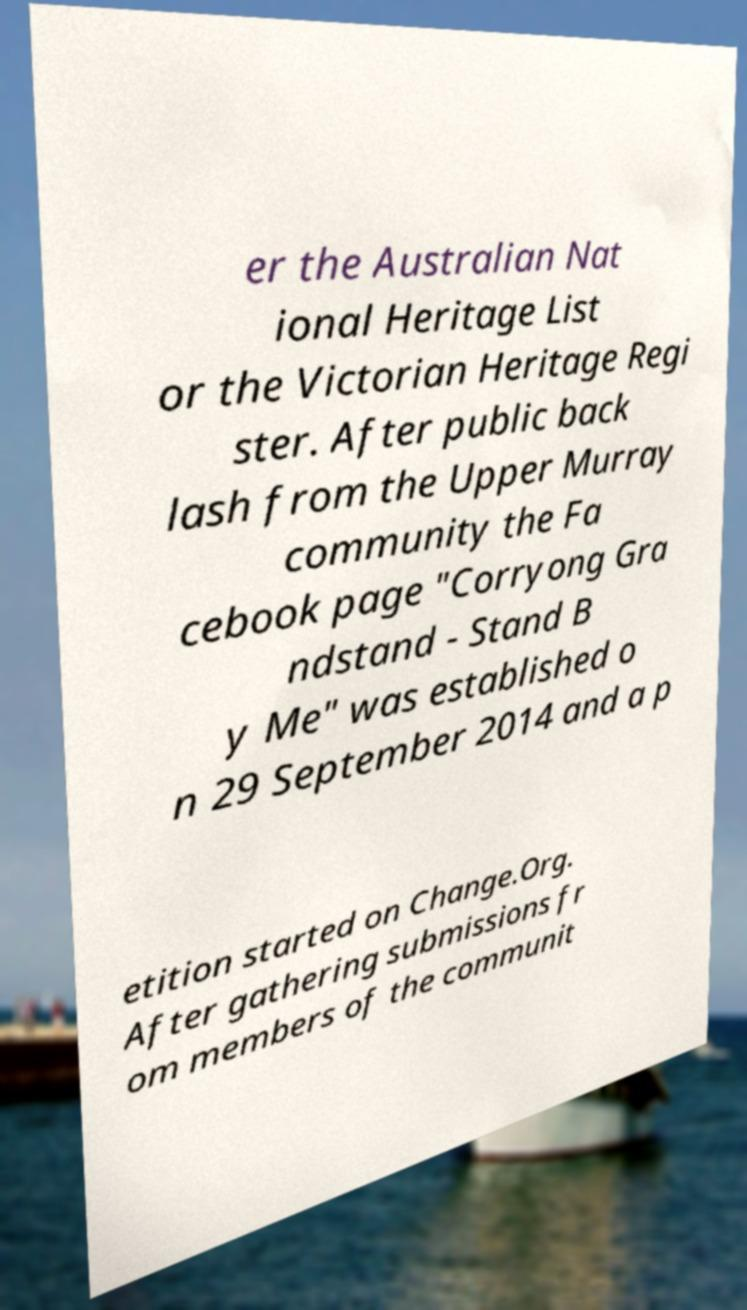What messages or text are displayed in this image? I need them in a readable, typed format. er the Australian Nat ional Heritage List or the Victorian Heritage Regi ster. After public back lash from the Upper Murray community the Fa cebook page "Corryong Gra ndstand - Stand B y Me" was established o n 29 September 2014 and a p etition started on Change.Org. After gathering submissions fr om members of the communit 